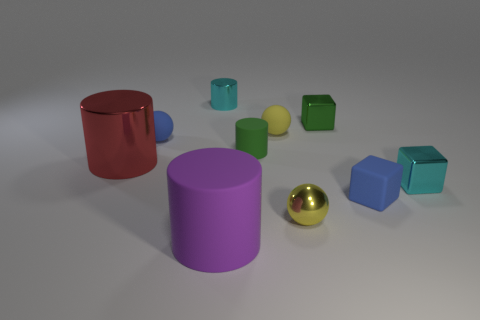There is a cylinder in front of the metallic block right of the small green cube; what size is it?
Give a very brief answer. Large. There is a blue sphere that is made of the same material as the blue cube; what size is it?
Your response must be concise. Small. There is a rubber thing that is in front of the large red cylinder and behind the purple cylinder; what is its shape?
Your answer should be very brief. Cube. Is the number of small blue things that are on the left side of the small yellow matte ball the same as the number of small cyan cylinders?
Offer a terse response. Yes. What number of objects are blue rubber blocks or small blue objects that are on the right side of the small green shiny block?
Keep it short and to the point. 1. Are there any small green things that have the same shape as the big purple rubber object?
Your answer should be very brief. Yes. Are there an equal number of blue balls behind the tiny metallic cylinder and rubber blocks that are in front of the tiny green block?
Your answer should be compact. No. What number of brown objects are cylinders or big metal balls?
Provide a succinct answer. 0. What number of cyan metallic blocks are the same size as the green cylinder?
Your response must be concise. 1. There is a metal thing that is both behind the small blue sphere and to the right of the tiny metal cylinder; what is its color?
Make the answer very short. Green. 